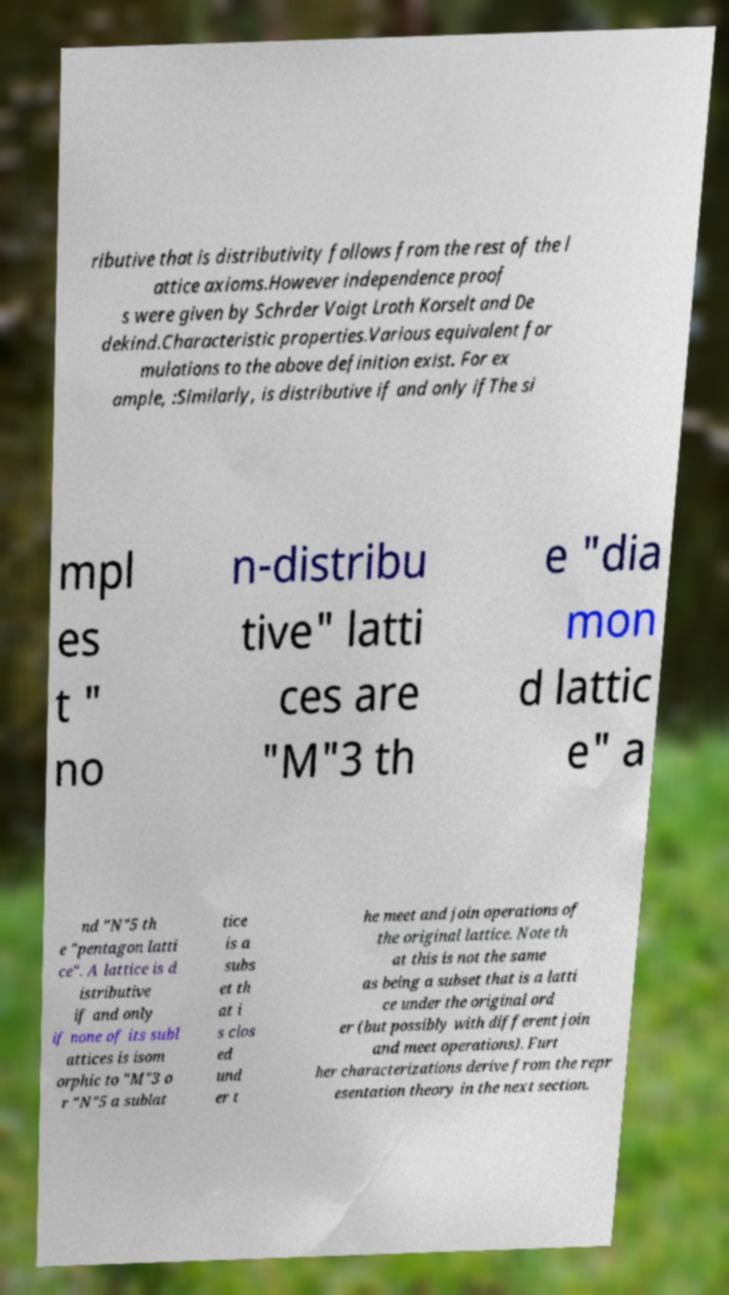There's text embedded in this image that I need extracted. Can you transcribe it verbatim? ributive that is distributivity follows from the rest of the l attice axioms.However independence proof s were given by Schrder Voigt Lroth Korselt and De dekind.Characteristic properties.Various equivalent for mulations to the above definition exist. For ex ample, :Similarly, is distributive if and only ifThe si mpl es t " no n-distribu tive" latti ces are "M"3 th e "dia mon d lattic e" a nd "N"5 th e "pentagon latti ce". A lattice is d istributive if and only if none of its subl attices is isom orphic to "M"3 o r "N"5 a sublat tice is a subs et th at i s clos ed und er t he meet and join operations of the original lattice. Note th at this is not the same as being a subset that is a latti ce under the original ord er (but possibly with different join and meet operations). Furt her characterizations derive from the repr esentation theory in the next section. 